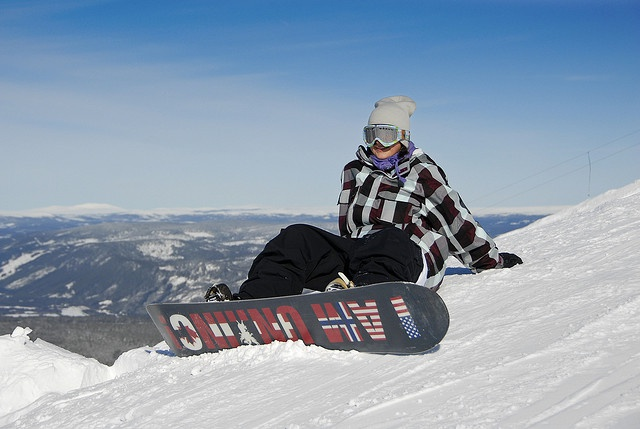Describe the objects in this image and their specific colors. I can see people in gray, black, darkgray, and lightgray tones and snowboard in gray, brown, darkblue, and lightgray tones in this image. 